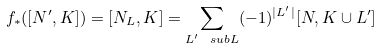<formula> <loc_0><loc_0><loc_500><loc_500>f _ { * } ( [ N ^ { \prime } , K ] ) = [ N _ { L } , K ] = \sum _ { L ^ { \prime } \ s u b L } ( - 1 ) ^ { | L ^ { \prime } | } [ N , K \cup L ^ { \prime } ]</formula> 